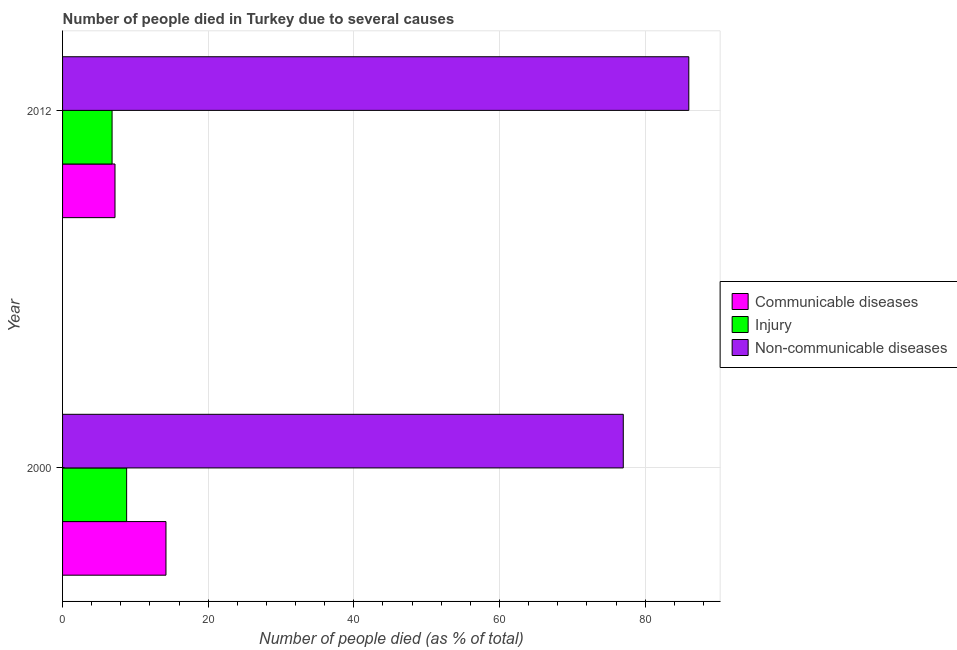How many bars are there on the 1st tick from the top?
Keep it short and to the point. 3. What is the label of the 1st group of bars from the top?
Your response must be concise. 2012. In how many cases, is the number of bars for a given year not equal to the number of legend labels?
Your response must be concise. 0. What is the number of people who died of injury in 2012?
Your answer should be very brief. 6.8. Across all years, what is the maximum number of people who died of communicable diseases?
Your answer should be very brief. 14.2. Across all years, what is the minimum number of people who dies of non-communicable diseases?
Your response must be concise. 77. In which year was the number of people who died of injury maximum?
Make the answer very short. 2000. In which year was the number of people who died of communicable diseases minimum?
Your answer should be very brief. 2012. What is the total number of people who dies of non-communicable diseases in the graph?
Provide a short and direct response. 163. What is the difference between the number of people who died of communicable diseases in 2000 and the number of people who dies of non-communicable diseases in 2012?
Provide a short and direct response. -71.8. In the year 2000, what is the difference between the number of people who died of injury and number of people who died of communicable diseases?
Your answer should be very brief. -5.4. What is the ratio of the number of people who died of communicable diseases in 2000 to that in 2012?
Offer a terse response. 1.97. What does the 2nd bar from the top in 2000 represents?
Provide a succinct answer. Injury. What does the 2nd bar from the bottom in 2012 represents?
Give a very brief answer. Injury. Is it the case that in every year, the sum of the number of people who died of communicable diseases and number of people who died of injury is greater than the number of people who dies of non-communicable diseases?
Give a very brief answer. No. How many bars are there?
Keep it short and to the point. 6. Are all the bars in the graph horizontal?
Give a very brief answer. Yes. How many years are there in the graph?
Your answer should be very brief. 2. What is the difference between two consecutive major ticks on the X-axis?
Keep it short and to the point. 20. Does the graph contain grids?
Provide a succinct answer. Yes. What is the title of the graph?
Make the answer very short. Number of people died in Turkey due to several causes. What is the label or title of the X-axis?
Your answer should be compact. Number of people died (as % of total). What is the label or title of the Y-axis?
Provide a short and direct response. Year. What is the Number of people died (as % of total) of Communicable diseases in 2000?
Your answer should be compact. 14.2. What is the Number of people died (as % of total) of Injury in 2000?
Your answer should be compact. 8.8. What is the Number of people died (as % of total) of Non-communicable diseases in 2000?
Provide a short and direct response. 77. What is the Number of people died (as % of total) of Communicable diseases in 2012?
Ensure brevity in your answer.  7.2. What is the Number of people died (as % of total) in Injury in 2012?
Offer a terse response. 6.8. What is the Number of people died (as % of total) in Non-communicable diseases in 2012?
Keep it short and to the point. 86. Across all years, what is the maximum Number of people died (as % of total) in Injury?
Provide a short and direct response. 8.8. Across all years, what is the minimum Number of people died (as % of total) of Communicable diseases?
Provide a short and direct response. 7.2. Across all years, what is the minimum Number of people died (as % of total) in Non-communicable diseases?
Ensure brevity in your answer.  77. What is the total Number of people died (as % of total) of Communicable diseases in the graph?
Provide a short and direct response. 21.4. What is the total Number of people died (as % of total) in Non-communicable diseases in the graph?
Your answer should be very brief. 163. What is the difference between the Number of people died (as % of total) in Communicable diseases in 2000 and that in 2012?
Offer a terse response. 7. What is the difference between the Number of people died (as % of total) in Injury in 2000 and that in 2012?
Give a very brief answer. 2. What is the difference between the Number of people died (as % of total) of Non-communicable diseases in 2000 and that in 2012?
Offer a very short reply. -9. What is the difference between the Number of people died (as % of total) of Communicable diseases in 2000 and the Number of people died (as % of total) of Injury in 2012?
Provide a succinct answer. 7.4. What is the difference between the Number of people died (as % of total) in Communicable diseases in 2000 and the Number of people died (as % of total) in Non-communicable diseases in 2012?
Your answer should be compact. -71.8. What is the difference between the Number of people died (as % of total) of Injury in 2000 and the Number of people died (as % of total) of Non-communicable diseases in 2012?
Your response must be concise. -77.2. What is the average Number of people died (as % of total) of Non-communicable diseases per year?
Make the answer very short. 81.5. In the year 2000, what is the difference between the Number of people died (as % of total) in Communicable diseases and Number of people died (as % of total) in Non-communicable diseases?
Ensure brevity in your answer.  -62.8. In the year 2000, what is the difference between the Number of people died (as % of total) of Injury and Number of people died (as % of total) of Non-communicable diseases?
Keep it short and to the point. -68.2. In the year 2012, what is the difference between the Number of people died (as % of total) of Communicable diseases and Number of people died (as % of total) of Injury?
Provide a short and direct response. 0.4. In the year 2012, what is the difference between the Number of people died (as % of total) in Communicable diseases and Number of people died (as % of total) in Non-communicable diseases?
Keep it short and to the point. -78.8. In the year 2012, what is the difference between the Number of people died (as % of total) of Injury and Number of people died (as % of total) of Non-communicable diseases?
Keep it short and to the point. -79.2. What is the ratio of the Number of people died (as % of total) of Communicable diseases in 2000 to that in 2012?
Make the answer very short. 1.97. What is the ratio of the Number of people died (as % of total) of Injury in 2000 to that in 2012?
Give a very brief answer. 1.29. What is the ratio of the Number of people died (as % of total) of Non-communicable diseases in 2000 to that in 2012?
Offer a terse response. 0.9. What is the difference between the highest and the second highest Number of people died (as % of total) of Communicable diseases?
Provide a succinct answer. 7. What is the difference between the highest and the second highest Number of people died (as % of total) of Injury?
Your answer should be compact. 2. What is the difference between the highest and the second highest Number of people died (as % of total) in Non-communicable diseases?
Give a very brief answer. 9. 